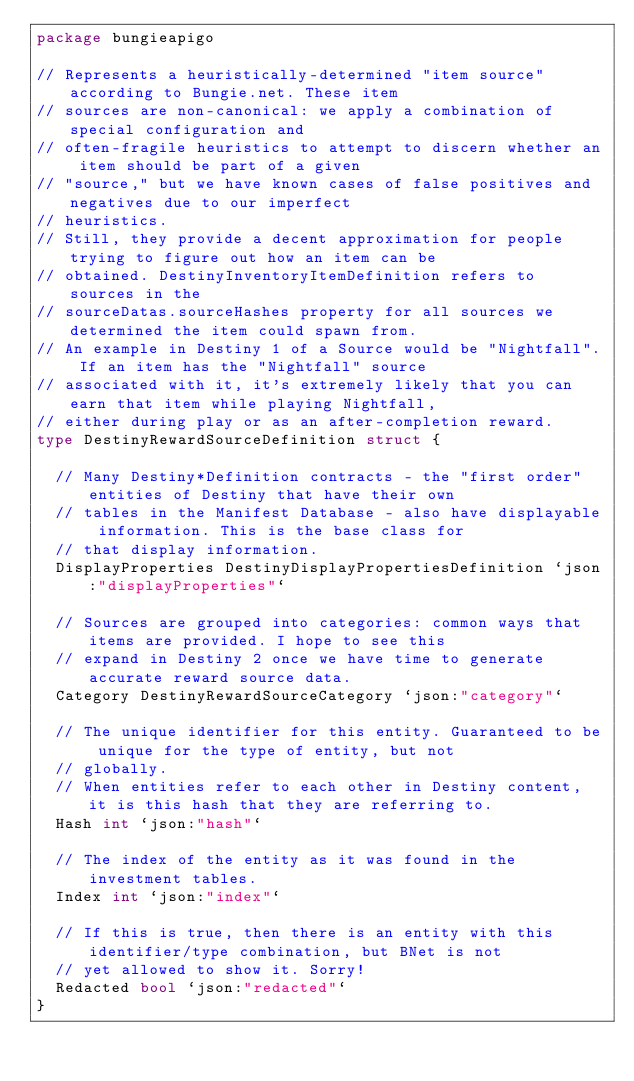<code> <loc_0><loc_0><loc_500><loc_500><_Go_>package bungieapigo

// Represents a heuristically-determined "item source" according to Bungie.net. These item
// sources are non-canonical: we apply a combination of special configuration and
// often-fragile heuristics to attempt to discern whether an item should be part of a given
// "source," but we have known cases of false positives and negatives due to our imperfect
// heuristics.
// Still, they provide a decent approximation for people trying to figure out how an item can be
// obtained. DestinyInventoryItemDefinition refers to sources in the
// sourceDatas.sourceHashes property for all sources we determined the item could spawn from.
// An example in Destiny 1 of a Source would be "Nightfall". If an item has the "Nightfall" source
// associated with it, it's extremely likely that you can earn that item while playing Nightfall,
// either during play or as an after-completion reward.
type DestinyRewardSourceDefinition struct {

	// Many Destiny*Definition contracts - the "first order" entities of Destiny that have their own
	// tables in the Manifest Database - also have displayable information. This is the base class for
	// that display information.
	DisplayProperties DestinyDisplayPropertiesDefinition `json:"displayProperties"`

	// Sources are grouped into categories: common ways that items are provided. I hope to see this
	// expand in Destiny 2 once we have time to generate accurate reward source data.
	Category DestinyRewardSourceCategory `json:"category"`

	// The unique identifier for this entity. Guaranteed to be unique for the type of entity, but not
	// globally.
	// When entities refer to each other in Destiny content, it is this hash that they are referring to.
	Hash int `json:"hash"`

	// The index of the entity as it was found in the investment tables.
	Index int `json:"index"`

	// If this is true, then there is an entity with this identifier/type combination, but BNet is not
	// yet allowed to show it. Sorry!
	Redacted bool `json:"redacted"`
}
</code> 